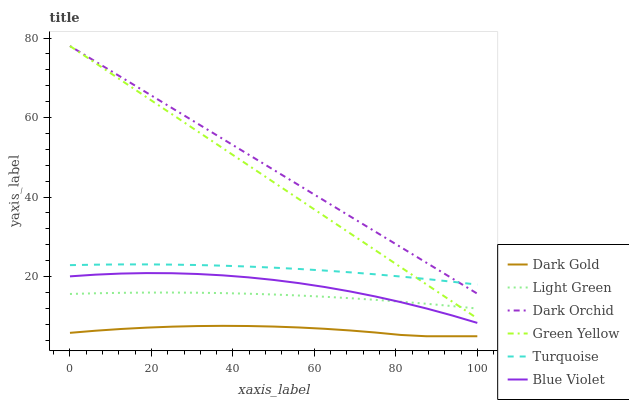Does Dark Gold have the minimum area under the curve?
Answer yes or no. Yes. Does Dark Orchid have the maximum area under the curve?
Answer yes or no. Yes. Does Dark Orchid have the minimum area under the curve?
Answer yes or no. No. Does Dark Gold have the maximum area under the curve?
Answer yes or no. No. Is Dark Orchid the smoothest?
Answer yes or no. Yes. Is Blue Violet the roughest?
Answer yes or no. Yes. Is Dark Gold the smoothest?
Answer yes or no. No. Is Dark Gold the roughest?
Answer yes or no. No. Does Dark Gold have the lowest value?
Answer yes or no. Yes. Does Dark Orchid have the lowest value?
Answer yes or no. No. Does Green Yellow have the highest value?
Answer yes or no. Yes. Does Dark Gold have the highest value?
Answer yes or no. No. Is Dark Gold less than Turquoise?
Answer yes or no. Yes. Is Dark Orchid greater than Blue Violet?
Answer yes or no. Yes. Does Turquoise intersect Green Yellow?
Answer yes or no. Yes. Is Turquoise less than Green Yellow?
Answer yes or no. No. Is Turquoise greater than Green Yellow?
Answer yes or no. No. Does Dark Gold intersect Turquoise?
Answer yes or no. No. 